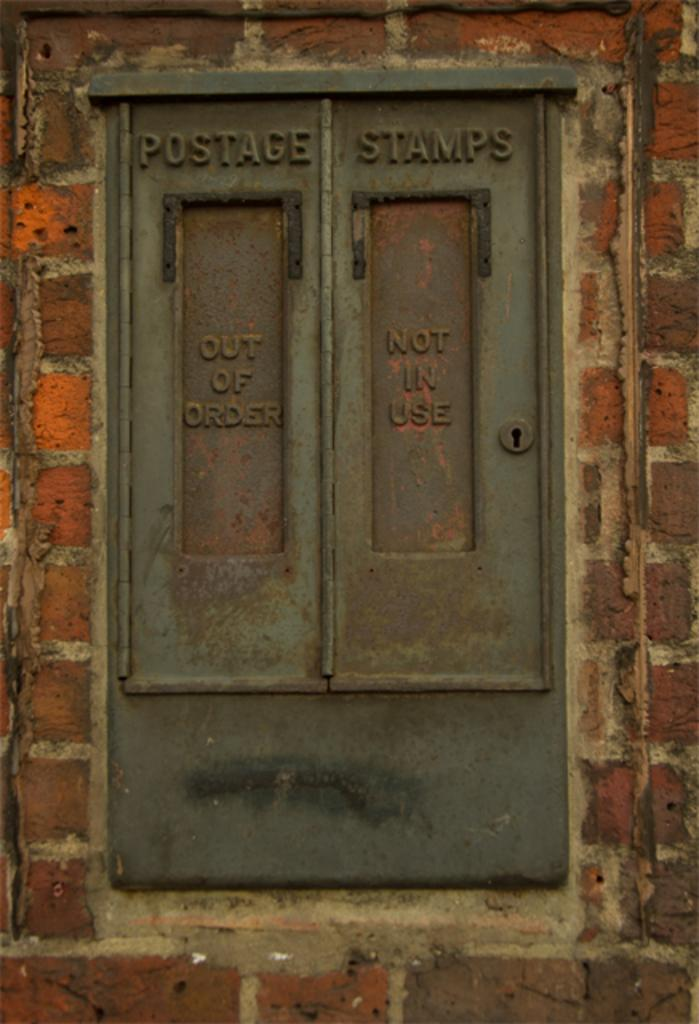What can be seen on a wall in the image? There is a window on a wall in the image. What is the purpose of the window in the image? The window allows light to enter the room and provides a view of the outside. What is written or displayed on the window? There is text on the window. Can you tell me how many screws are visible on the window in the image? There is no mention of screws in the provided facts, so we cannot determine the number of screws visible on the window in the image. 